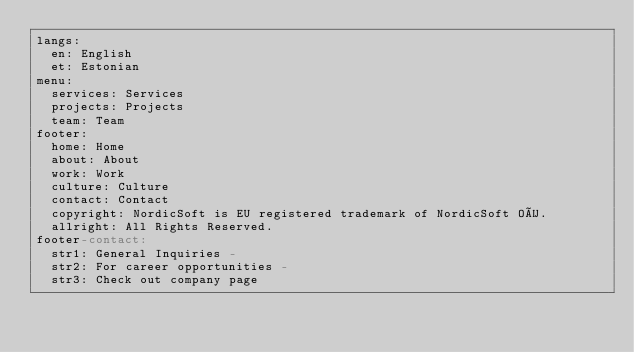Convert code to text. <code><loc_0><loc_0><loc_500><loc_500><_YAML_>langs:
  en: English
  et: Estonian
menu:
  services: Services
  projects: Projects
  team: Team
footer:
  home: Home
  about: About
  work: Work
  culture: Culture
  contact: Contact
  copyright: NordicSoft is EU registered trademark of NordicSoft OÜ.
  allright: All Rights Reserved.
footer-contact:
  str1: General Inquiries -
  str2: For career opportunities -
  str3: Check out company page
</code> 